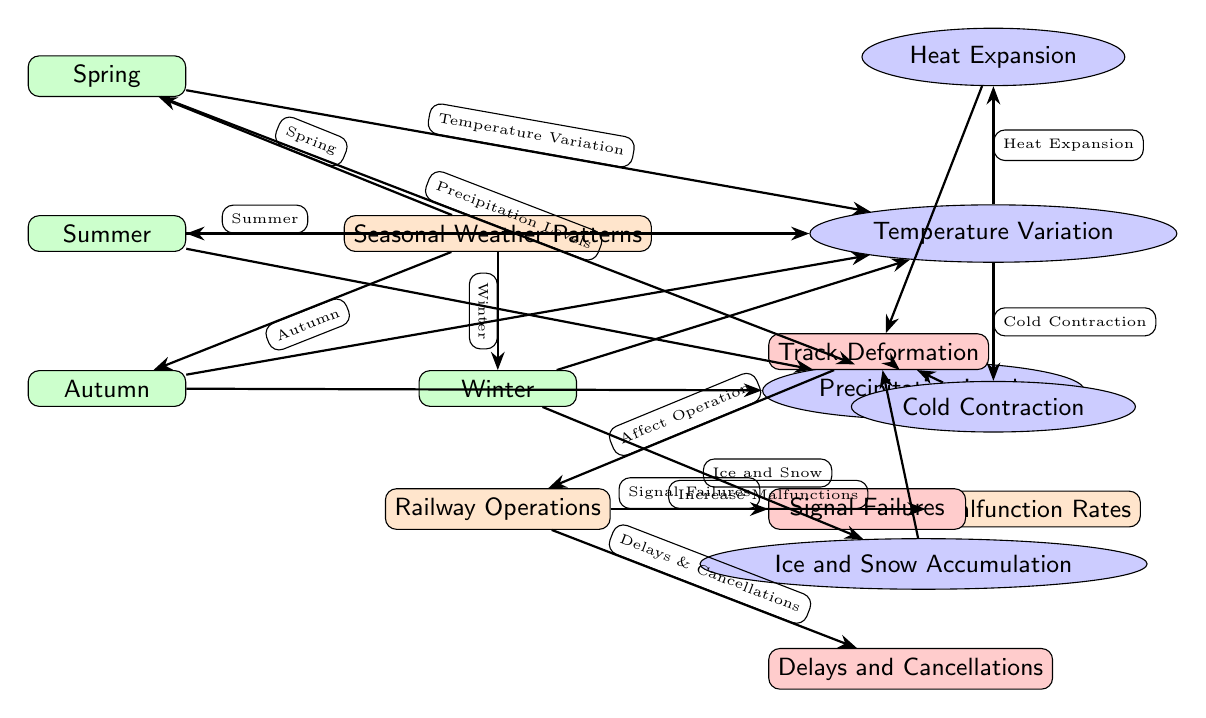What are the four seasonal weather patterns depicted? The diagram lists Spring, Summer, Autumn, and Winter as the four seasonal weather patterns. These were identified as the nodes branching from the main weather node.
Answer: Spring, Summer, Autumn, Winter How does temperature variation in Spring affect railway operations? In Spring, temperature variation leads to both heat expansion and cold contraction, influencing track deformation and railway operations negatively. This is observed through the connections from the Spring node to the temperature variation and its subsequent effects.
Answer: Track Deformation What are the two factors directly linked to Summer weather conditions? The diagram shows that in Summer, the two factors affecting railway operations are Temperature Variation and Precipitation Levels, as indicated by the arrows connecting Summer to these factors.
Answer: Temperature Variation and Precipitation Levels What effect does ice and snow accumulation have on railway operations? Ice and snow accumulation directly results in track deformation, which is a key factor causing malfunctions and operational issues in railways, as shown by the arrows from the ice and snow node to track.
Answer: Track Deformation Which factor is linked to a higher malfunction rate during Winter? The factor linked to a higher malfunction rate during Winter is Ice and Snow Accumulation, which leads to significant operational challenges as seen in the diagram.
Answer: Ice and Snow Accumulation What is the primary effect of track deformation on railway operations? Track deformation primarily results in a higher rate of delays and cancellations in railway operations, as indicated by the direct connection from track deformation to delays and cancellations.
Answer: Delays and Cancellations What is the first effect shown resulting from temperature variation? The first effect shown resulting from temperature variation is Heat Expansion, as indicated in the diagram where temperature variation splits into both heat expansion and cold contraction.
Answer: Heat Expansion How many main nodes are identified in the diagram? The diagram identifies three main nodes: Seasonal Weather Patterns, Railway Operations, and Malfunction Rates, which are the primary categories the diagram focuses on.
Answer: Three What connection is observed between railway operations and signal failures? The connection observed is that railway operations directly influence signal failures, as there is an arrow drawn from the railway node to the signal failures node, indicating this relationship.
Answer: Signal Failures 